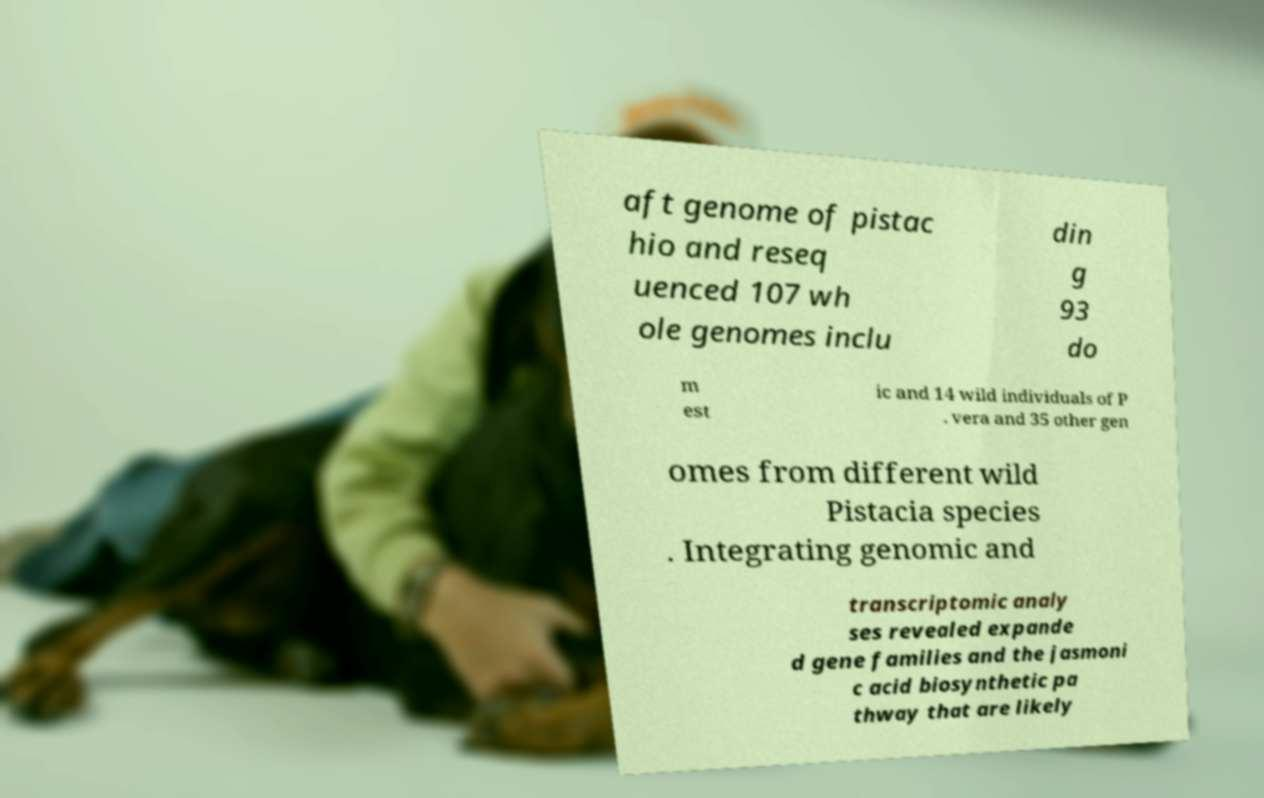For documentation purposes, I need the text within this image transcribed. Could you provide that? aft genome of pistac hio and reseq uenced 107 wh ole genomes inclu din g 93 do m est ic and 14 wild individuals of P . vera and 35 other gen omes from different wild Pistacia species . Integrating genomic and transcriptomic analy ses revealed expande d gene families and the jasmoni c acid biosynthetic pa thway that are likely 